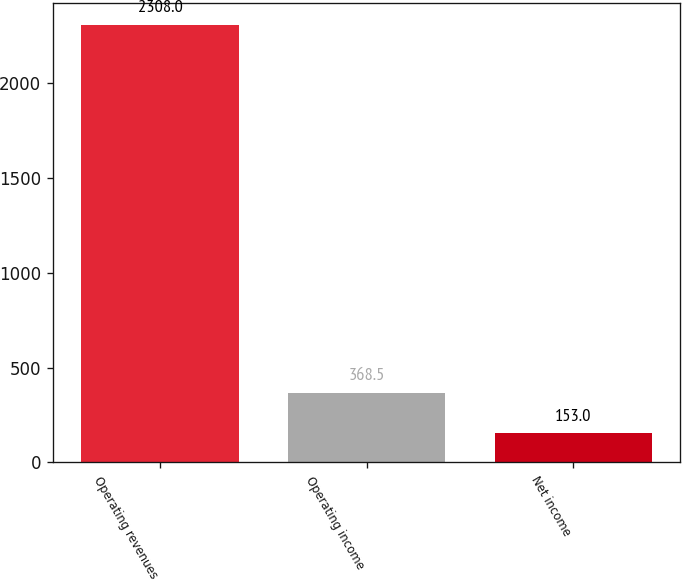<chart> <loc_0><loc_0><loc_500><loc_500><bar_chart><fcel>Operating revenues<fcel>Operating income<fcel>Net income<nl><fcel>2308<fcel>368.5<fcel>153<nl></chart> 